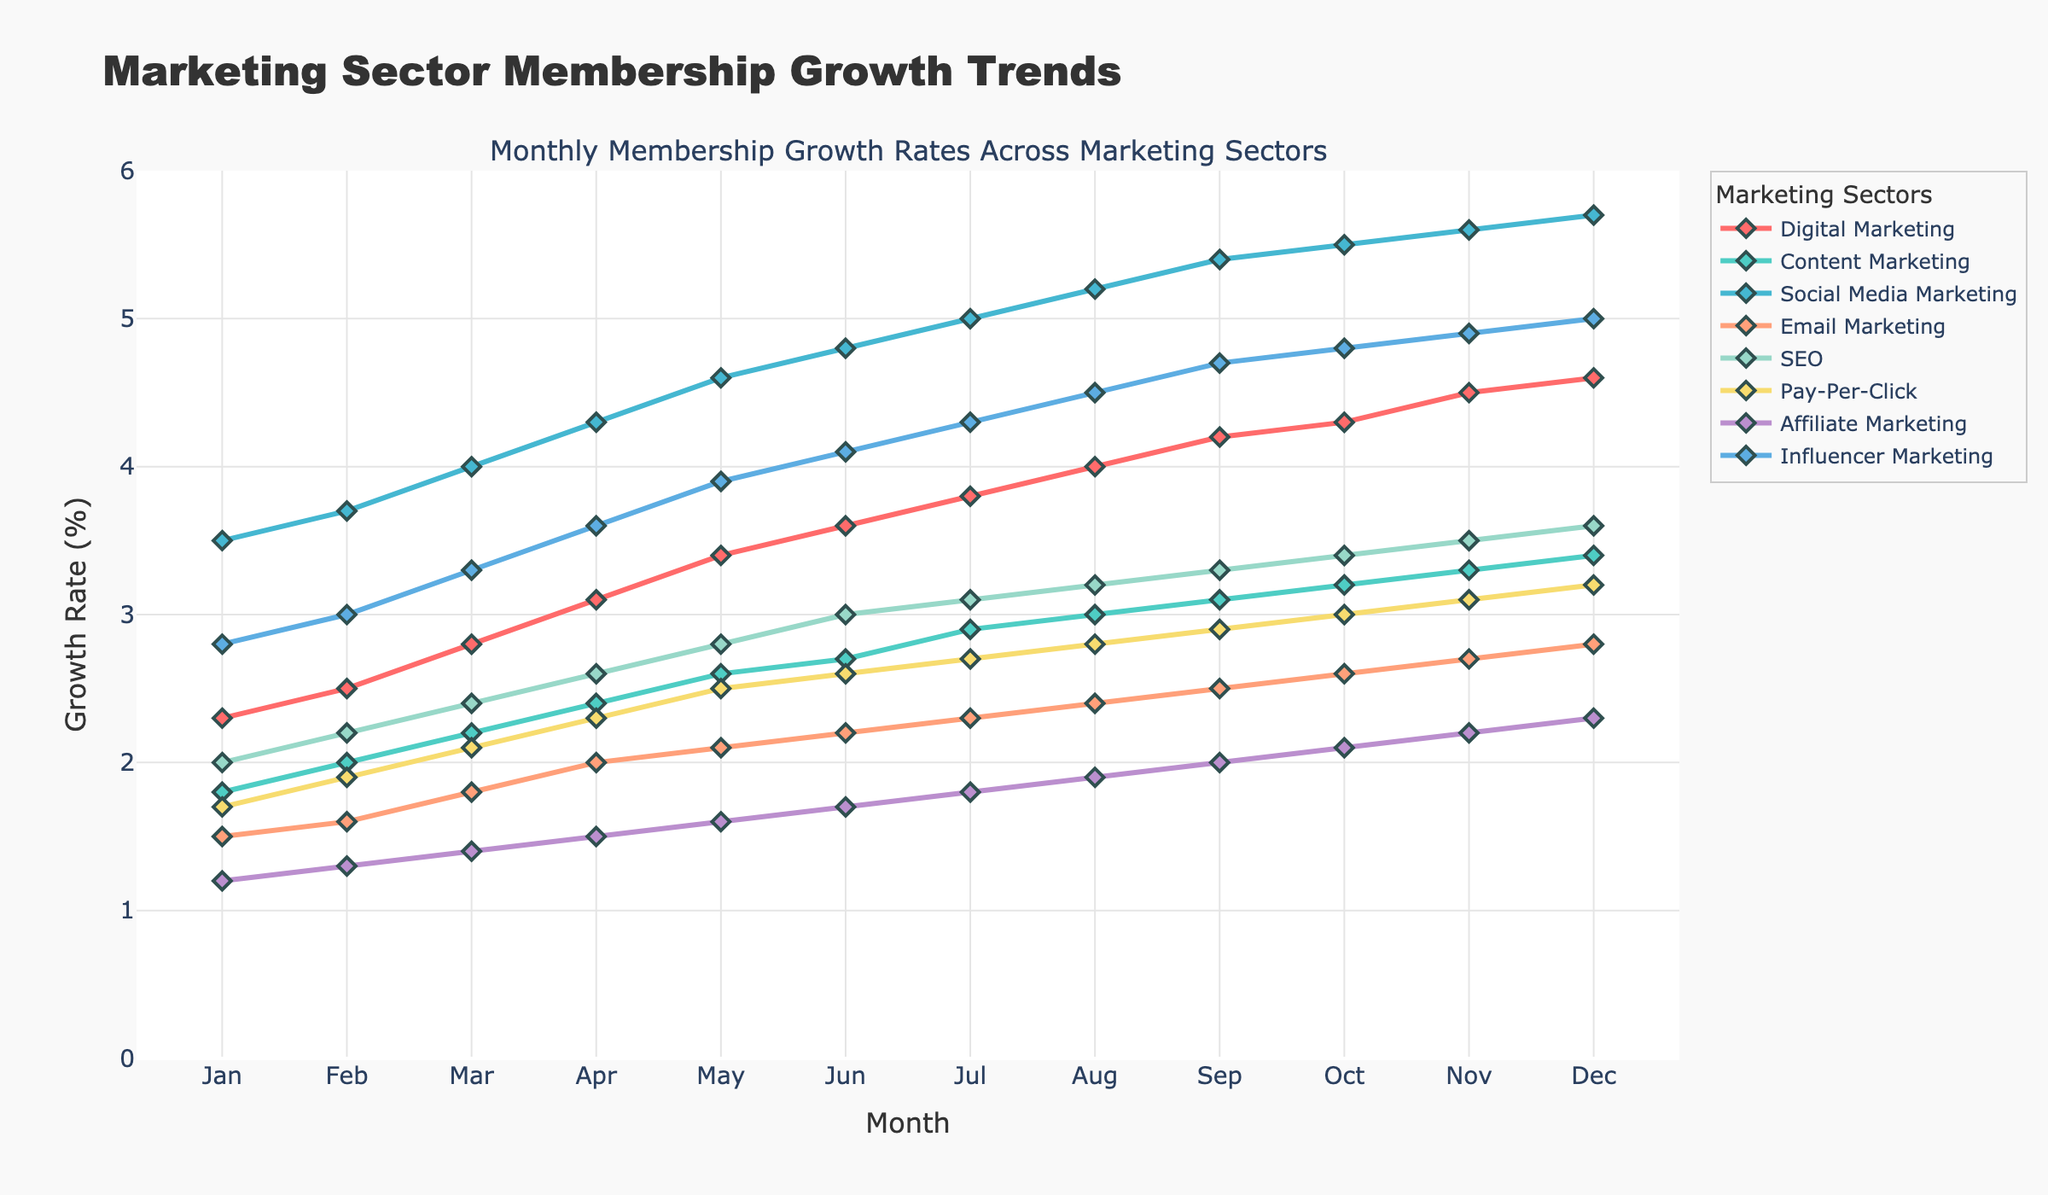Which sector had the highest growth rate in March? In the month of March, the highest growth rate is the peak data point, which is 4.0%, represented by Social Media Marketing in the chart.
Answer: Social Media Marketing Which sector experienced the lowest growth rate in January? The lowest growth rate in January is 1.2%, represented by Affiliate Marketing.
Answer: Affiliate Marketing How many sectors had growth rates greater than 3.0% in September? In September, the growth rates greater than 3.0% are for Social Media Marketing (5.4%), Influencer Marketing (4.7%), and Digital Marketing (4.2%). There are three such sectors.
Answer: 3 Which sector showed the most consistent growth throughout the year? The most consistent growth is characterized by the least variability in the graph, represented by fairly even and smooth lines. Content Marketing appears as the most consistent growth pattern on the chart.
Answer: Content Marketing Between which two consecutive months did Digital Marketing have the largest increase in growth rate? By examining the slope of the Digital Marketing line, the steepest increase is between April and May, from 3.1% to 3.4%, a 0.3% increase.
Answer: April and May What is the overall trend for Email Marketing throughout the year? The overall trend for Email Marketing is represented by a steadily increasing growth rate from 1.5% in January to 2.8% in December.
Answer: Steadily increasing How does the growth rate of Pay-Per-Click in February compare to SEO in February? In February, the growth rate for Pay-Per-Click is 1.9%, whereas for SEO it is 2.2%. Thus, Pay-Per-Click's growth rate is lower.
Answer: Lower Which sector showed the fastest growth in November? In November, the fastest growth is shown by the highest value, 5.6%, represented by Social Media Marketing.
Answer: Social Media Marketing What is the average growth rate of Influencer Marketing for the first six months? Influencer Marketing growth rates for the first six months are 2.8, 3.0, 3.3, 3.6, 3.9, and 4.1%. The sum is 2.8+3.0+3.3+3.6+3.9+4.1 = 20.7, and the average is 20.7 / 6 = 3.45%.
Answer: 3.45% How much higher was Social Media Marketing's growth rate in December than Email Marketing's growth rate in December? In December, Social Media Marketing's growth rate was 5.7%, and Email Marketing's was 2.8%. The difference is 5.7% - 2.8% = 2.9%.
Answer: 2.9% 